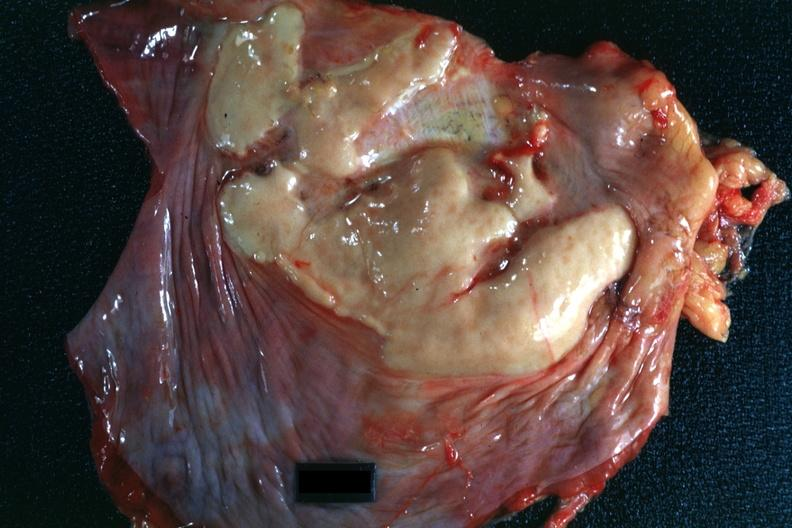s muscle present?
Answer the question using a single word or phrase. Yes 